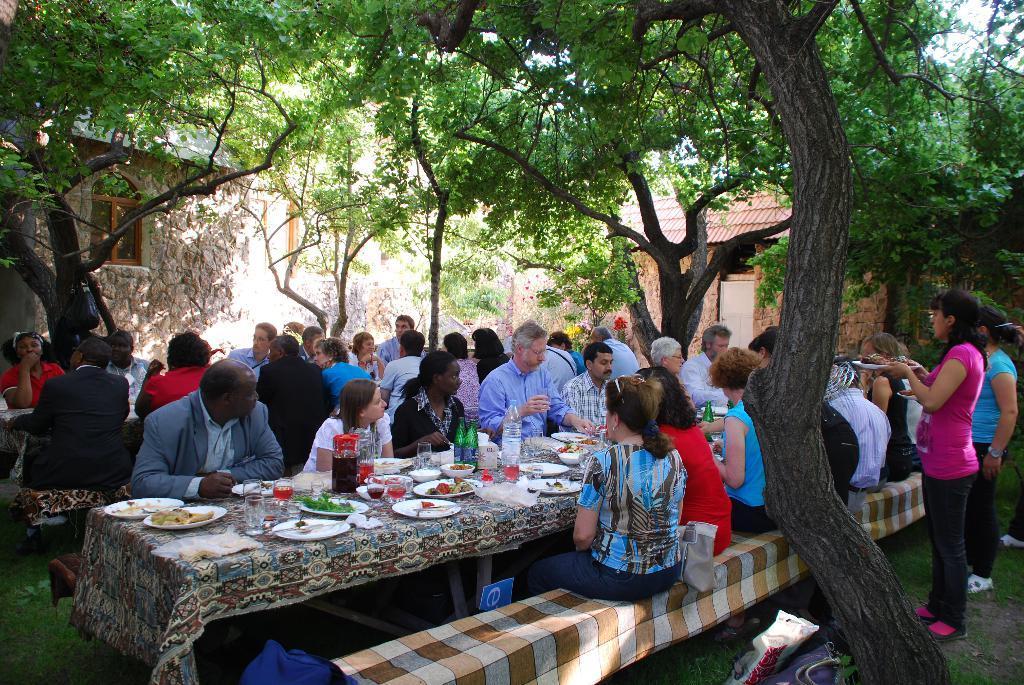How would you summarize this image in a sentence or two? In this image, there are some persons wearing colorful clothes and sitting under trees. There is a table in front of this persons covered with a cloth. This table contains plates, glasses and plates. There are two persons standing behind these persons. There is a building behind these persons. 